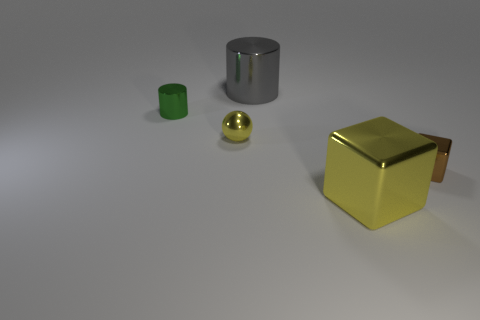Are there any objects of the same color as the sphere?
Keep it short and to the point. Yes. There is a big metal cube; does it have the same color as the tiny metal ball that is left of the brown block?
Give a very brief answer. Yes. There is a gray cylinder behind the metallic block that is in front of the small brown shiny block; what is its material?
Your answer should be very brief. Metal. There is a tiny cylinder that is the same material as the yellow sphere; what color is it?
Your answer should be very brief. Green. The thing that is the same color as the small metal ball is what shape?
Ensure brevity in your answer.  Cube. Do the metal object behind the small green shiny thing and the yellow thing that is in front of the brown cube have the same size?
Provide a short and direct response. Yes. How many spheres are either small red rubber objects or yellow things?
Provide a short and direct response. 1. What number of other objects are the same size as the yellow sphere?
Offer a terse response. 2. What number of big things are gray cylinders or blocks?
Give a very brief answer. 2. Does the small ball have the same color as the big shiny block?
Give a very brief answer. Yes. 